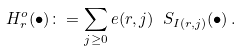Convert formula to latex. <formula><loc_0><loc_0><loc_500><loc_500>H _ { r } ^ { o } ( \bullet ) \colon = \sum _ { j \geq 0 } e ( r , j ) \ S _ { I ( r , j ) } ( \bullet ) \, .</formula> 